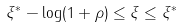<formula> <loc_0><loc_0><loc_500><loc_500>\xi ^ { * } - \log ( 1 + \rho ) \leq \xi \leq \xi ^ { * }</formula> 